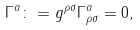Convert formula to latex. <formula><loc_0><loc_0><loc_500><loc_500>\Gamma ^ { \alpha } \colon = g ^ { \rho \sigma } \Gamma ^ { \alpha } _ { \rho \sigma } = 0 ,</formula> 